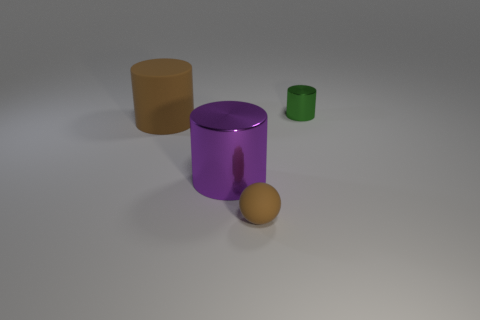Looking at the composition, what can you say about the objects' arrangement? The objects are arranged with an emphasis on balance and simplicity, with ample negative space around them. This creates a clean, minimalist aesthetic that draws attention to the shapes and colors of the items. 